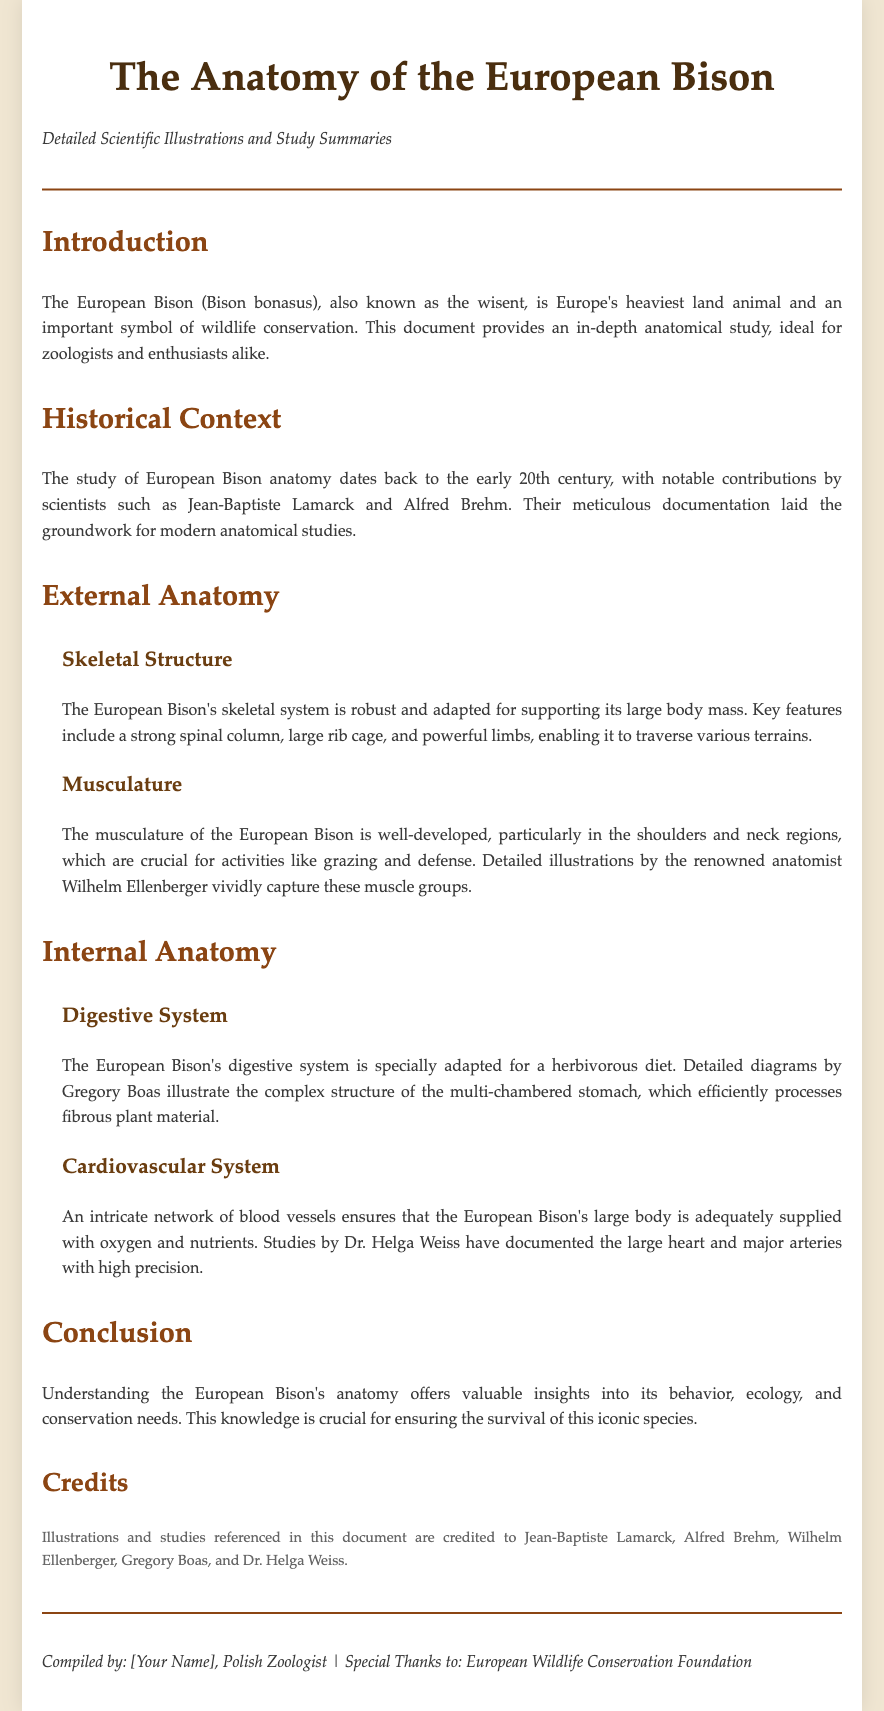What is the scientific name of the European Bison? The scientific name is mentioned in the introduction section of the document.
Answer: Bison bonasus Who contributed significantly to the study of European Bison anatomy? The historical context section notes key contributors.
Answer: Jean-Baptiste Lamarck and Alfred Brehm What anatomical system is adapted for a herbivorous diet in the European Bison? This information is found in the internal anatomy section discussing dietary adaptations.
Answer: Digestive System Which anatomist created illustrations of the musculature of the European Bison? The external anatomy section includes specific contributions of notable scientists.
Answer: Wilhelm Ellenberger In what year did the study of European Bison anatomy gain notable attention? The document refers to the early 20th century as the period of significant contributions.
Answer: Early 20th century What is a primary function of the European Bison's robust skeletal structure? The section on skeletal structure highlights the capabilities of the bison's anatomy.
Answer: Supporting large body mass What are two key features of the cardiovascular system of the European Bison? The internal anatomy section explains structural details of the cardiovascular system.
Answer: Large heart and major arteries What is the primary purpose of this document? The introduction section describes the document's aim related to zoological study.
Answer: In-depth anatomical study Which foundation is acknowledged in the compilation credits? The footer section contains specific credit information about contributions and support.
Answer: European Wildlife Conservation Foundation 